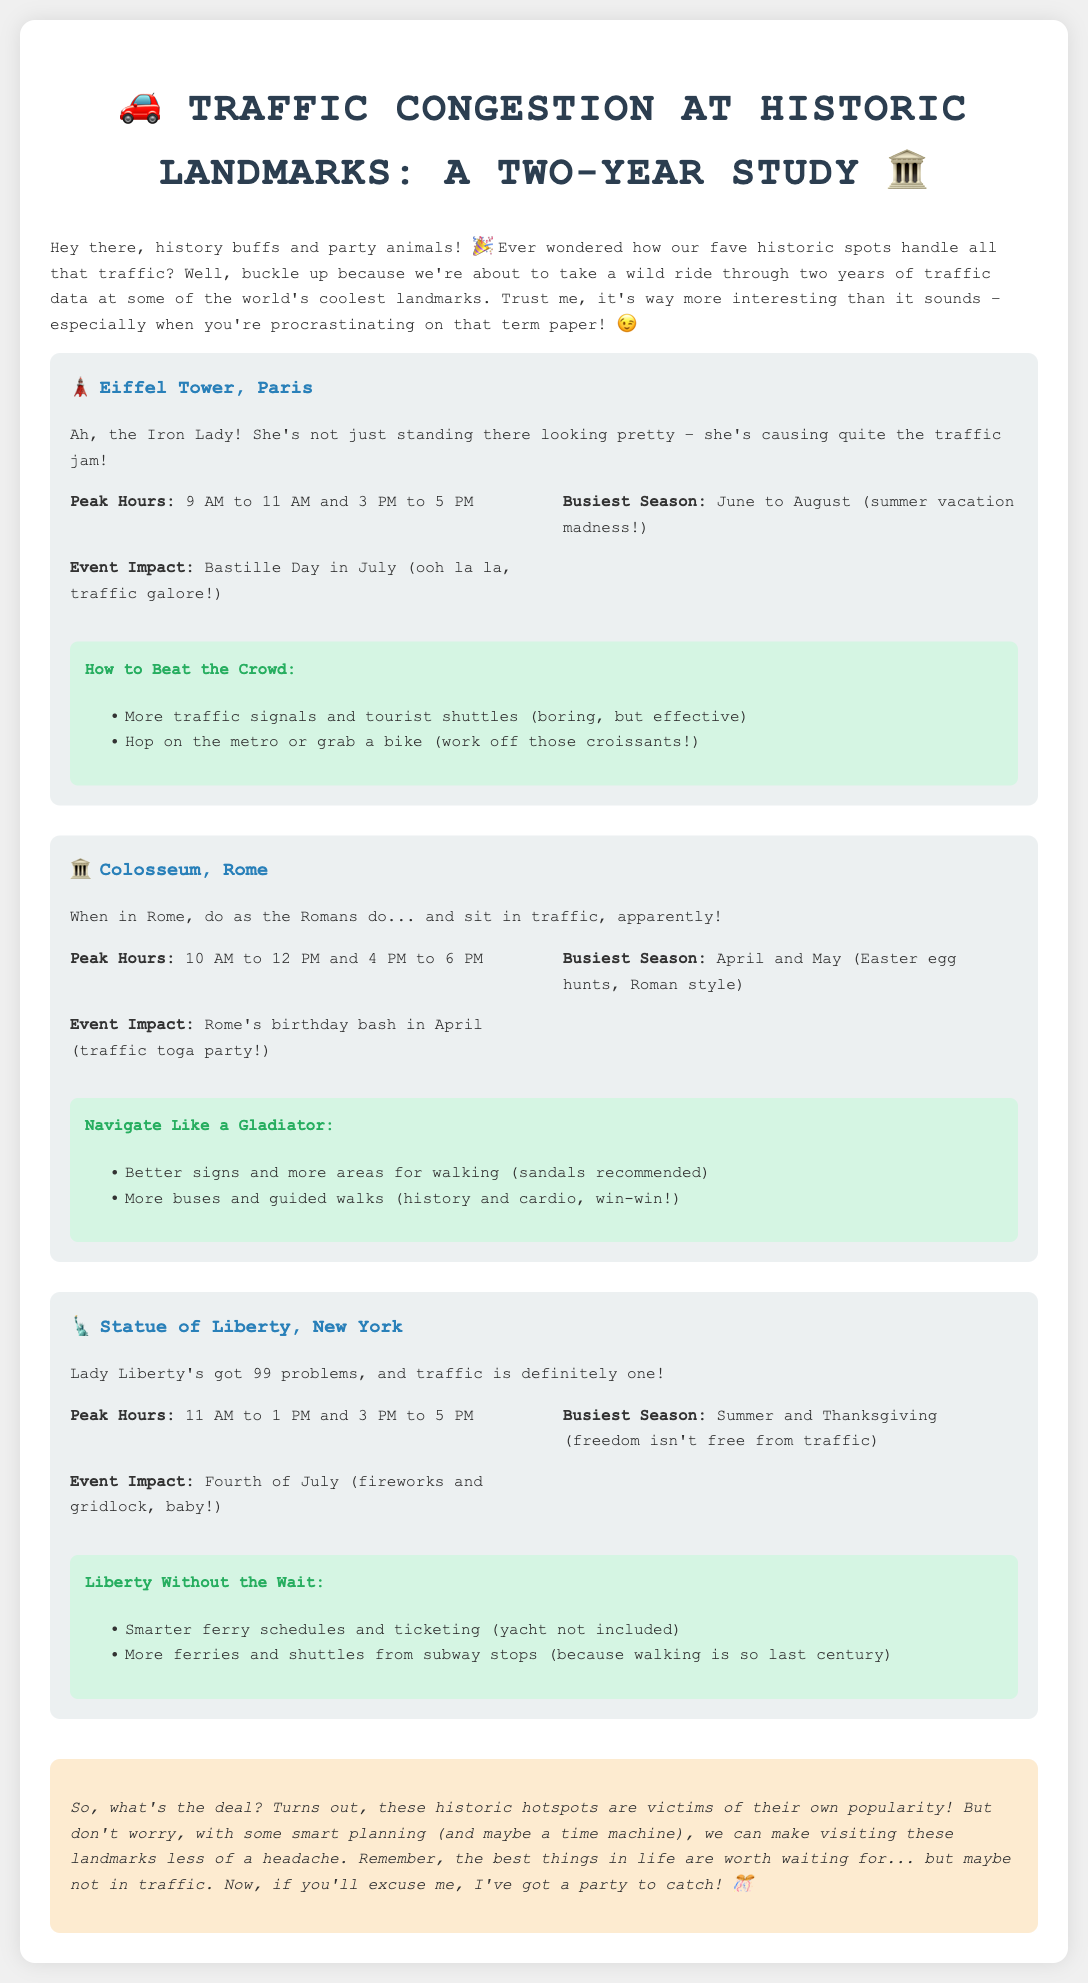What are the peak hours for the Eiffel Tower? The peak hours for the Eiffel Tower are specified in the document as "9 AM to 11 AM and 3 PM to 5 PM."
Answer: 9 AM to 11 AM and 3 PM to 5 PM What is the busiest season for the Colosseum? The document states the busiest season for the Colosseum as "April and May."
Answer: April and May Which historic landmark experiences the most traffic during the Fourth of July? The document mentions that the Statue of Liberty has traffic impacted by the "Fourth of July."
Answer: Statue of Liberty What recommendation is provided for navigating around the Colosseum? The document suggests "Better signs and more areas for walking" as a recommendation for the Colosseum.
Answer: Better signs and more areas for walking During which months does the Eiffel Tower experience its busiest season? The busiest season for the Eiffel Tower, as stated in the document, is "June to August."
Answer: June to August What is the event impact mentioned for the Statue of Liberty? The document notes that "Fourth of July" impacts traffic at the Statue of Liberty.
Answer: Fourth of July Which landmark has a recommendation to use the metro or a bike? The document recommends using the metro or a bike specifically for the "Eiffel Tower."
Answer: Eiffel Tower What is the peak hour range for the Colosseum? The peak hour range for the Colosseum is listed as "10 AM to 12 PM and 4 PM to 6 PM."
Answer: 10 AM to 12 PM and 4 PM to 6 PM What type of document is this? The document is a "Traffic Report" focused on "Traffic Congestion at Historic Landmarks."
Answer: Traffic Report 